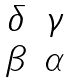<formula> <loc_0><loc_0><loc_500><loc_500>\begin{matrix} \delta & \gamma \\ \beta & \alpha \end{matrix}</formula> 